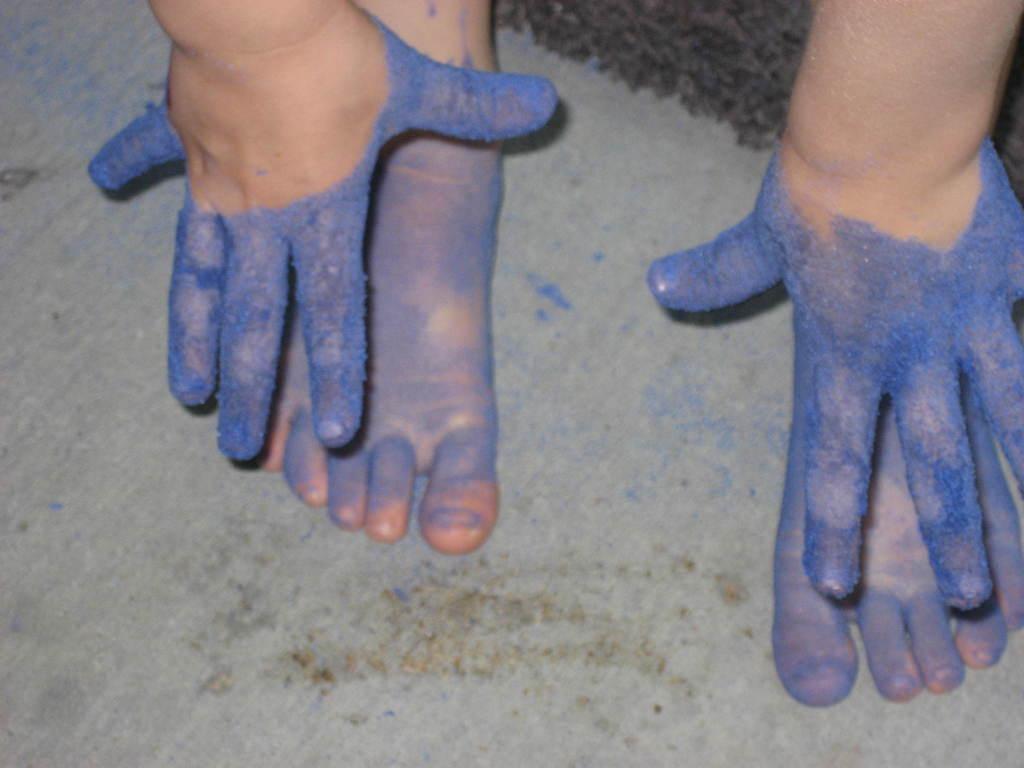Describe this image in one or two sentences. In this image I can see paws and feet of a kid dipped in blue color. 